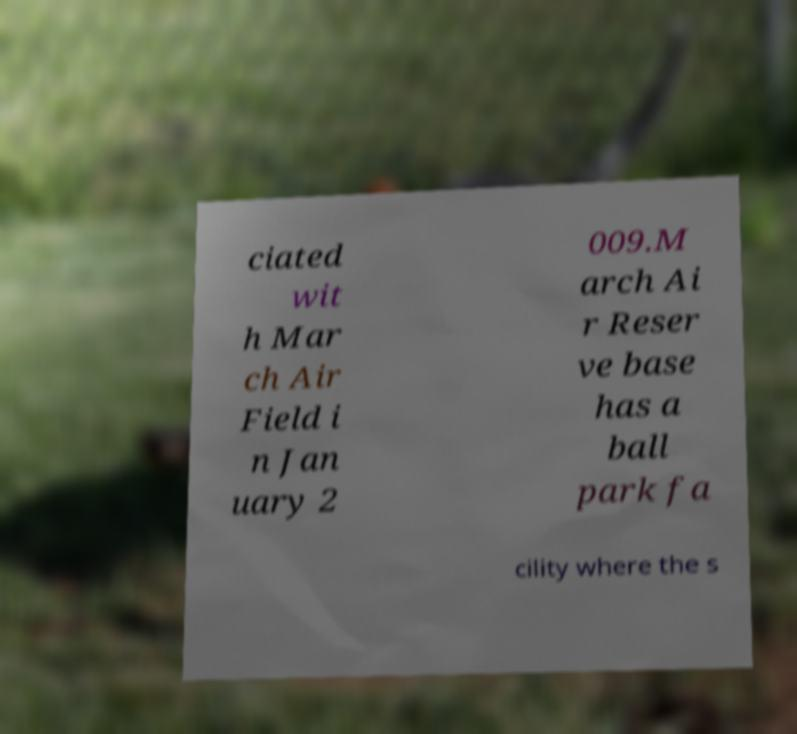I need the written content from this picture converted into text. Can you do that? ciated wit h Mar ch Air Field i n Jan uary 2 009.M arch Ai r Reser ve base has a ball park fa cility where the s 